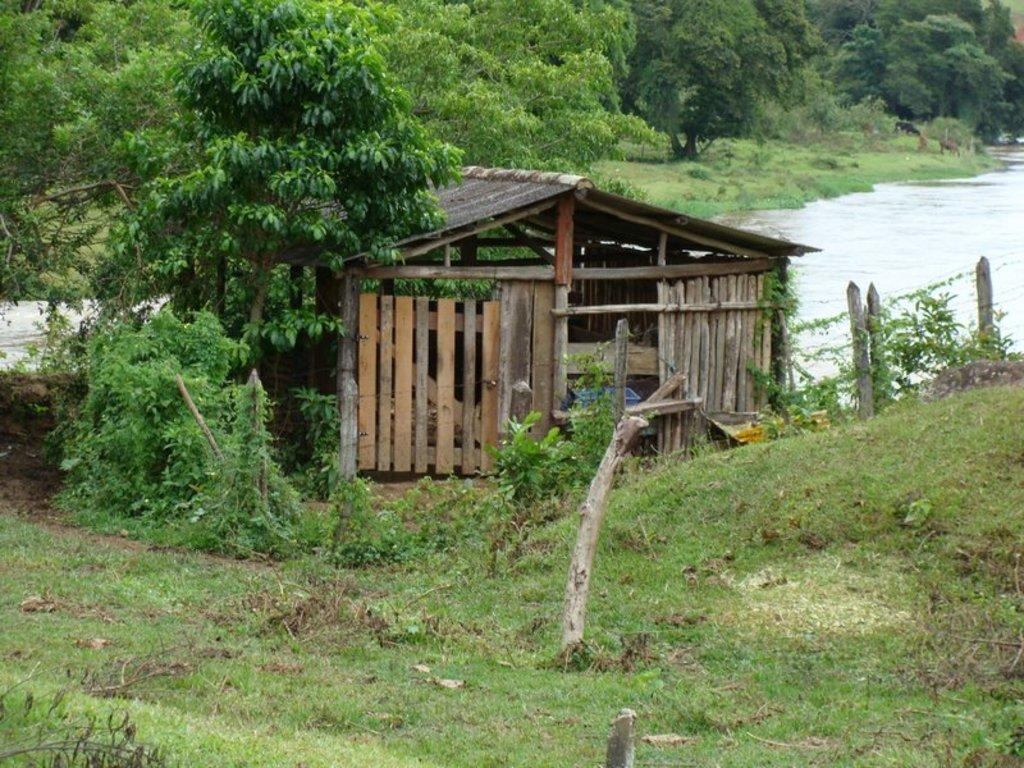What type of structure is in the image? There is a wooden shed house in the image. Where is the wooden shed house located? The wooden shed house is on the ground. What can be seen in the background of the image? There are many trees visible in the background of the image. What is on the right side of the image? There is a small river on the right side of the image. What type of vegetation is on the ground in the front side of the image? There is grass on the ground in the front side of the image. What is the frog writing on the basket in the image? There is no frog or basket present in the image. 